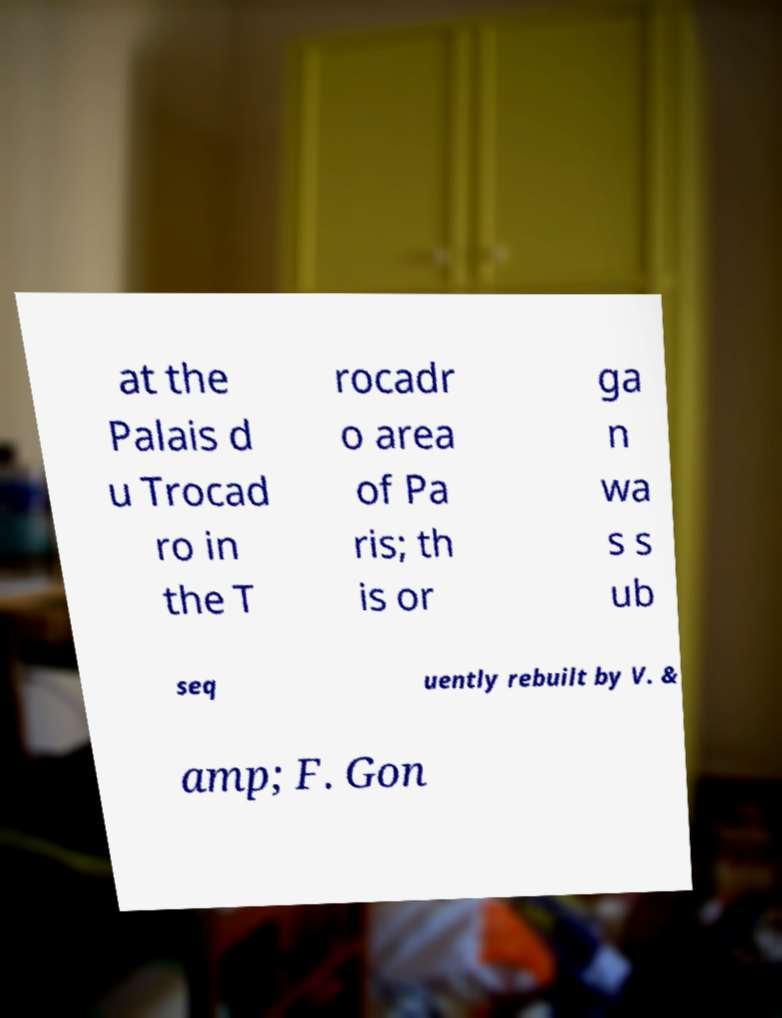Can you read and provide the text displayed in the image?This photo seems to have some interesting text. Can you extract and type it out for me? at the Palais d u Trocad ro in the T rocadr o area of Pa ris; th is or ga n wa s s ub seq uently rebuilt by V. & amp; F. Gon 